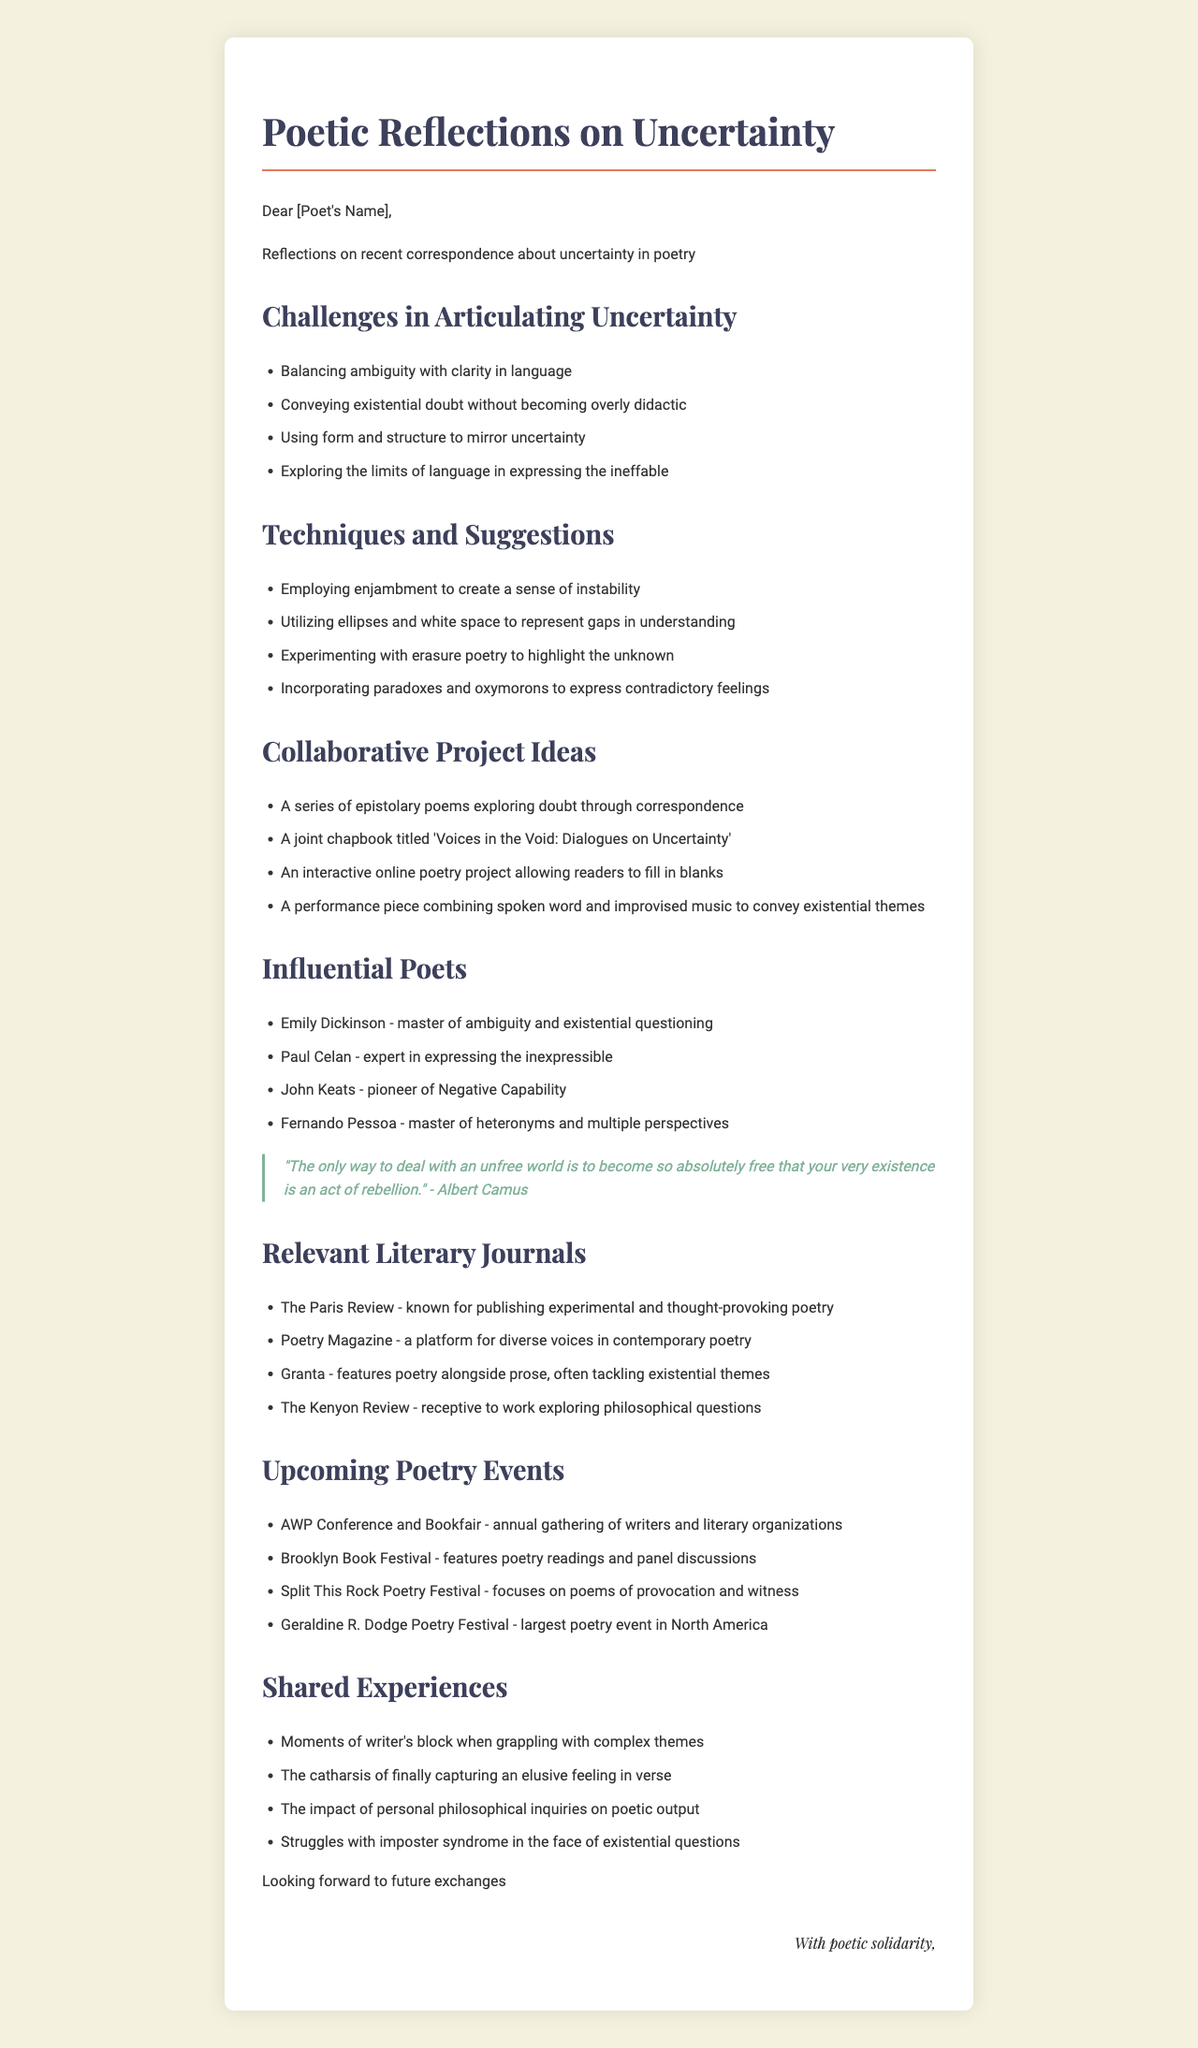What is the title of the letter? The title of the letter is indicated in the header and summarizes its main theme about uncertainty in poetry.
Answer: Poetic Reflections on Uncertainty Who is the letter addressed to? The recipient of the letter is mentioned in the salutation, inviting personal correspondence.
Answer: [Poet's Name] What is one challenge mentioned in articulating uncertainty? The document lists several challenges related to expressing doubt, which highlights the complexity of poetic language.
Answer: Balancing ambiguity with clarity in language Name one technique suggested for expressing uncertainty. Techniques to articulate doubt include various stylistic choices that can enhance the expression of existential themes.
Answer: Employing enjambment to create a sense of instability What is one collaborative project idea proposed? The letter includes several creative suggestions for projects that explore doubt, emphasizing collaboration in poetry.
Answer: A joint chapbook titled 'Voices in the Void: Dialogues on Uncertainty' Which poet is noted for expressing the inexpressible? The letter references influential poets, highlighting those whose works focus on themes of existentialism and doubt.
Answer: Paul Celan What is one notable upcoming poetry event? The document mentions events where poets gather, offering opportunities for performances and discussions.
Answer: AWP Conference and Bookfair List one relevant literary journal mentioned. The letter includes notable literary journals that publish work exploring philosophical and existential themes.
Answer: The Paris Review What is a shared experience discussed in the letter? The letter reflects on common experiences that poets face while navigating complex themes in their writing.
Answer: The catharsis of finally capturing an elusive feeling in verse 